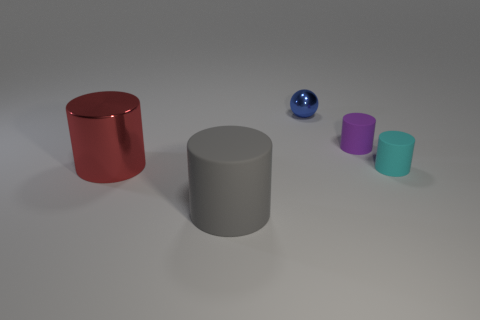Is the number of large matte objects that are behind the blue ball less than the number of gray cylinders?
Give a very brief answer. Yes. Are there any red things of the same size as the gray cylinder?
Give a very brief answer. Yes. What is the color of the big matte cylinder?
Provide a short and direct response. Gray. Is the size of the purple cylinder the same as the blue shiny ball?
Give a very brief answer. Yes. What number of things are cyan rubber things or big gray cylinders?
Provide a short and direct response. 2. Are there the same number of gray matte objects to the right of the cyan matte thing and purple rubber things?
Offer a terse response. No. Are there any objects that are left of the tiny metallic sphere behind the rubber thing that is to the left of the tiny ball?
Provide a succinct answer. Yes. The other small cylinder that is the same material as the small cyan cylinder is what color?
Provide a succinct answer. Purple. What number of cylinders are either large cyan objects or tiny shiny things?
Offer a terse response. 0. What size is the shiny object in front of the cylinder that is behind the large cylinder behind the big gray cylinder?
Your answer should be compact. Large. 